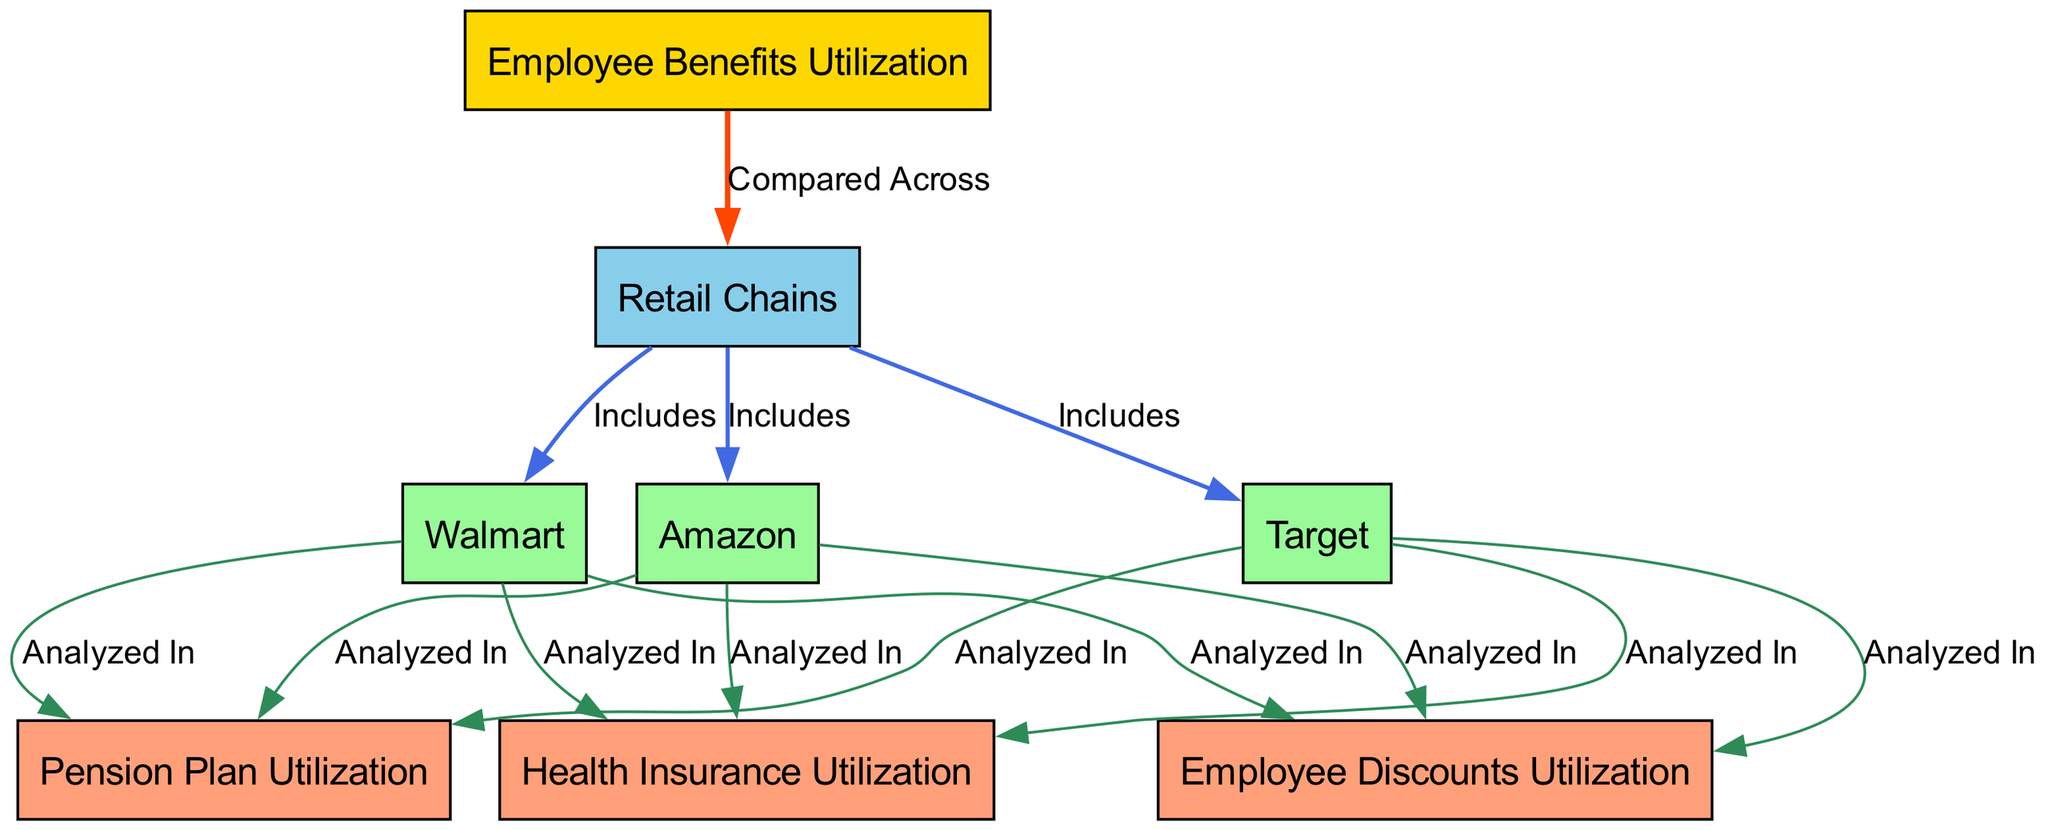What is the total number of retail chains analyzed in the diagram? The diagram includes three retail chains: Walmart, Target, and Amazon. Each of these is depicted as a node under the "Retail Chains" category. Thus, by counting these nodes, we find there are a total of three retail chains.
Answer: 3 Which benefit is analyzed for Walmart? The diagram indicates three specific benefits that are analyzed for Walmart: Health Insurance, Pension Plan, and Employee Discounts. Since the question refers to any one of these or a specific one without limitation, Health Insurance is a valid answer.
Answer: Health Insurance What color represents retail chains in the diagram? In the diagram, the nodes representing retail chains (Walmart, Target, Amazon) are filled with a light green color (#98FB98). This color coding differentiates them from other categories like Employee Benefits Utilization and Health Insurance. Thus, after spotting the style used for their nodes, the answer is the corresponding color.
Answer: Light green What is the relationship between employee benefits utilization and retail chains? The diagram shows that Employee Benefits Utilization is compared across the different retail chains, indicating a direct relationship where utilization rates can be analyzed among the chains listed. This connection is depicted by an arrow labeled "Compared Across." Therefore, the relationship in question relates to how benefits utilization is examined collectively among the identified retail chains.
Answer: Compared Across How many types of employee benefits are analyzed for Amazon? The diagram shows that three types of employee benefits are analyzed for Amazon: Health Insurance, Pension Plan, and Employee Discounts. Counting these benefits provides the total number specified for Amazon in the diagram context.
Answer: 3 What connects the retail chains to the benefits? The diagram illustrates that the retail chains (Walmart, Target, Amazon) have edges leading to three specific types of employee benefits (Health Insurance, Pension Plan, Employee Discounts). This connection signifies that each retail chain's utilization of these benefits is being studied, establishing a clear link from the chains to the benefits. The label specifying this connection is indicative of the analysis being conducted.
Answer: Analyzed In What benefit has the same analysis label for all retail chains? The analysis label "Analyzed In" is used consistently for all three types of employee benefits (Health Insurance, Pension Plan, Employee Discounts) across Walmart, Target, and Amazon. Each benefit is consequently analyzed for all retail chains, indicating uniformity in the analysis label assigned.
Answer: All benefits 